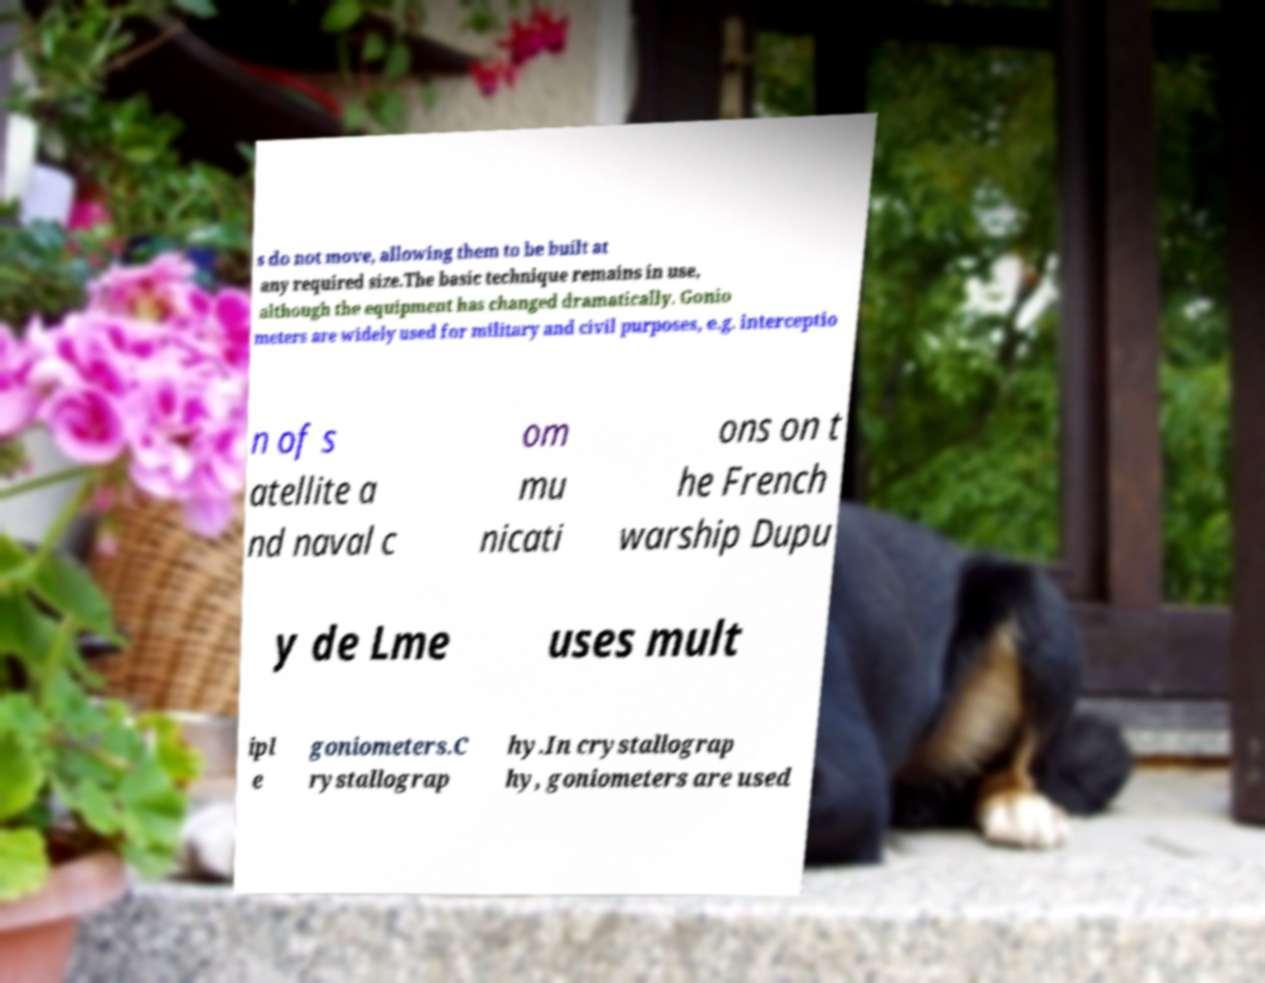Can you accurately transcribe the text from the provided image for me? s do not move, allowing them to be built at any required size.The basic technique remains in use, although the equipment has changed dramatically. Gonio meters are widely used for military and civil purposes, e.g. interceptio n of s atellite a nd naval c om mu nicati ons on t he French warship Dupu y de Lme uses mult ipl e goniometers.C rystallograp hy.In crystallograp hy, goniometers are used 